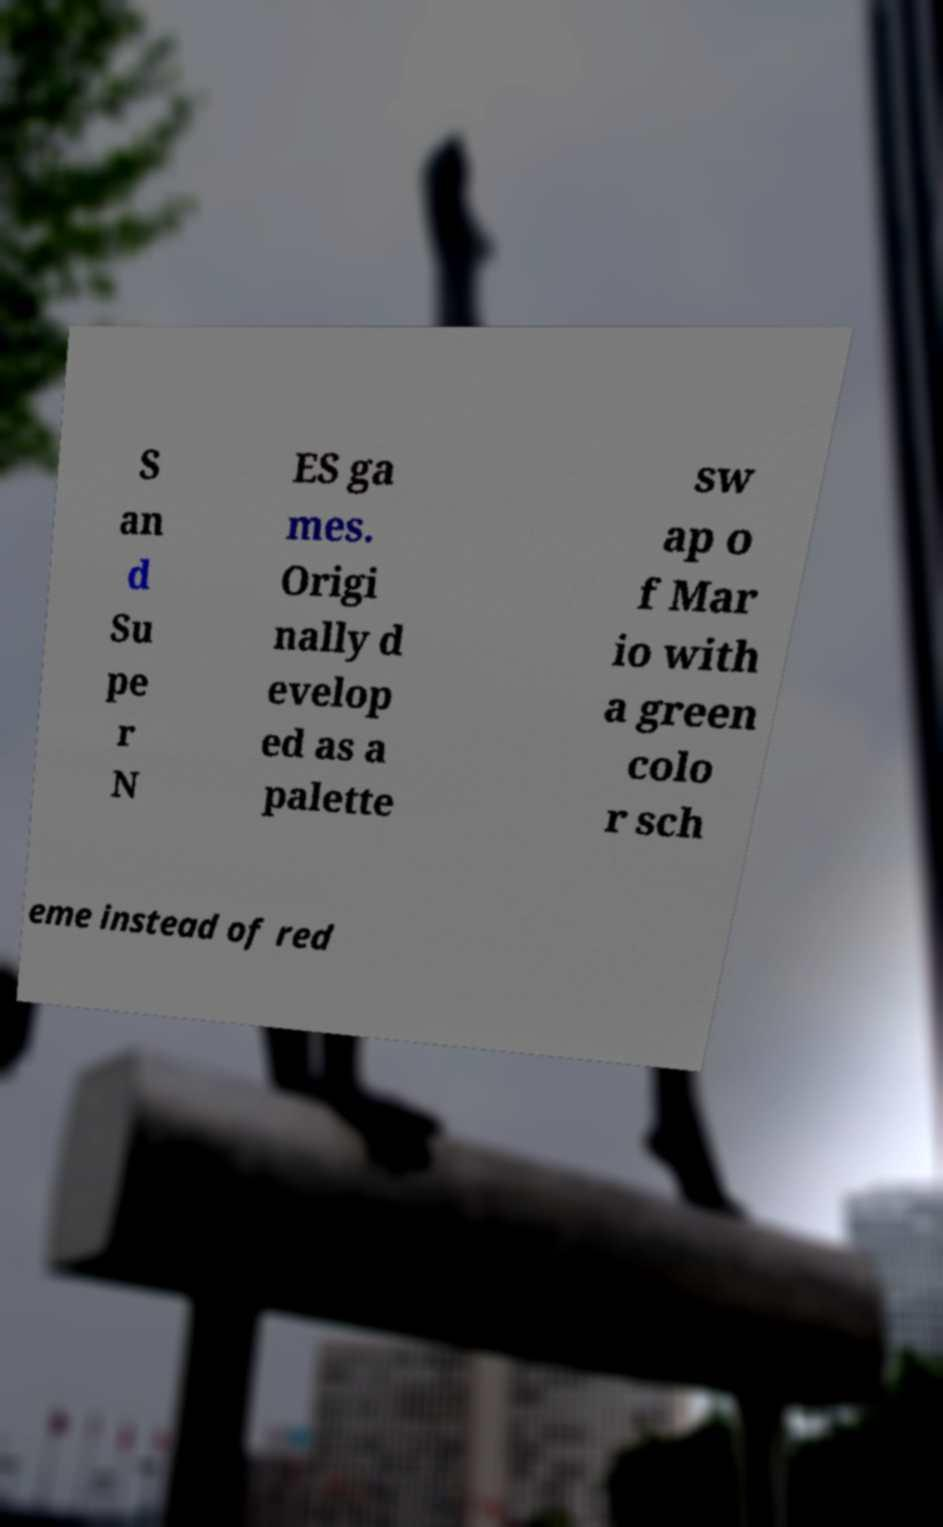Could you assist in decoding the text presented in this image and type it out clearly? S an d Su pe r N ES ga mes. Origi nally d evelop ed as a palette sw ap o f Mar io with a green colo r sch eme instead of red 